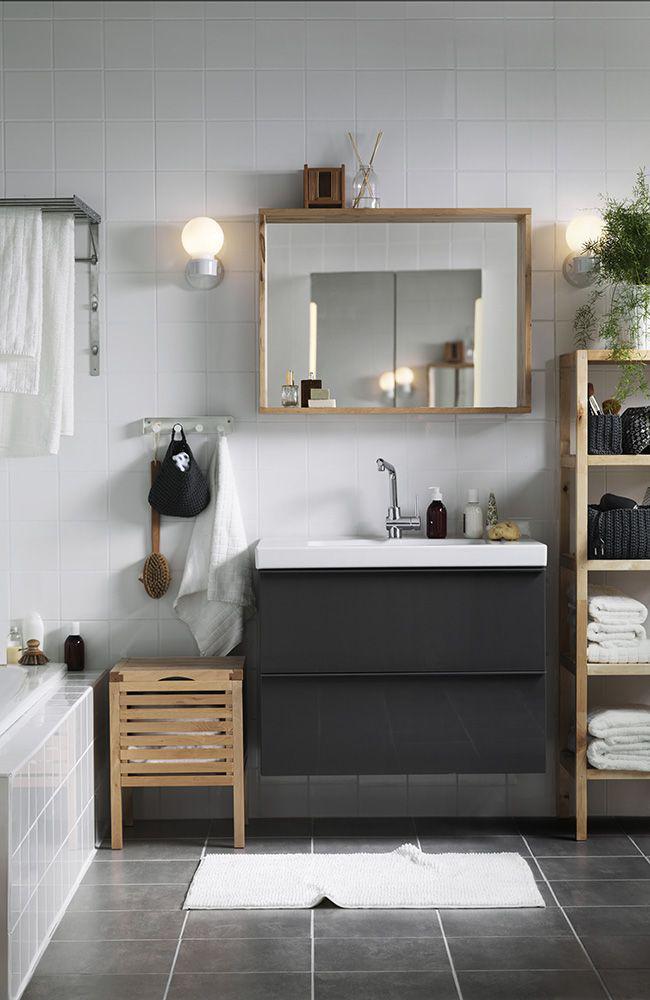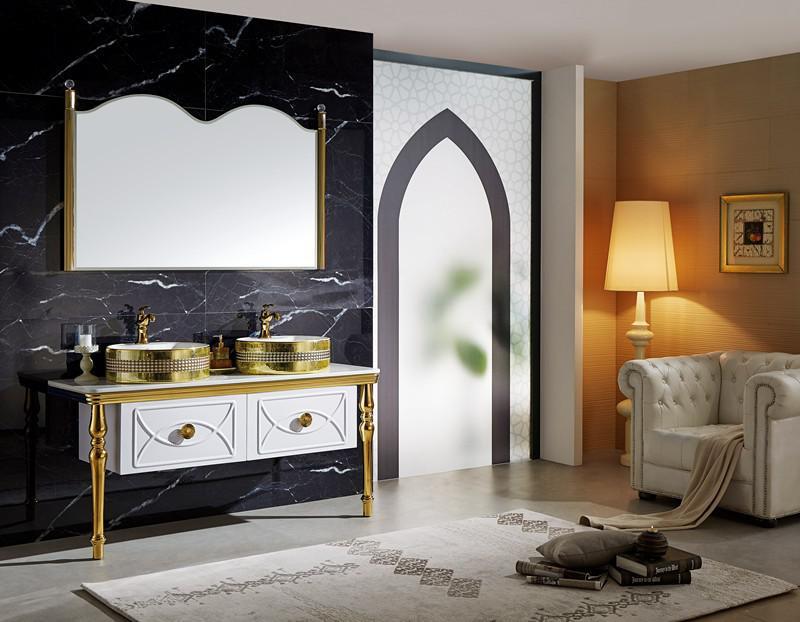The first image is the image on the left, the second image is the image on the right. Given the left and right images, does the statement "In one image, a wide footed vanity has two matching sinks mounted on top of the vanity and a one large mirror on the wall behind it." hold true? Answer yes or no. Yes. The first image is the image on the left, the second image is the image on the right. For the images displayed, is the sentence "An image shows a vanity with side-by-side sinks that rest atop the counter." factually correct? Answer yes or no. Yes. 